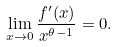Convert formula to latex. <formula><loc_0><loc_0><loc_500><loc_500>\lim _ { x \rightarrow 0 } \frac { f ^ { \prime } ( x ) } { x ^ { \theta - 1 } } = 0 .</formula> 